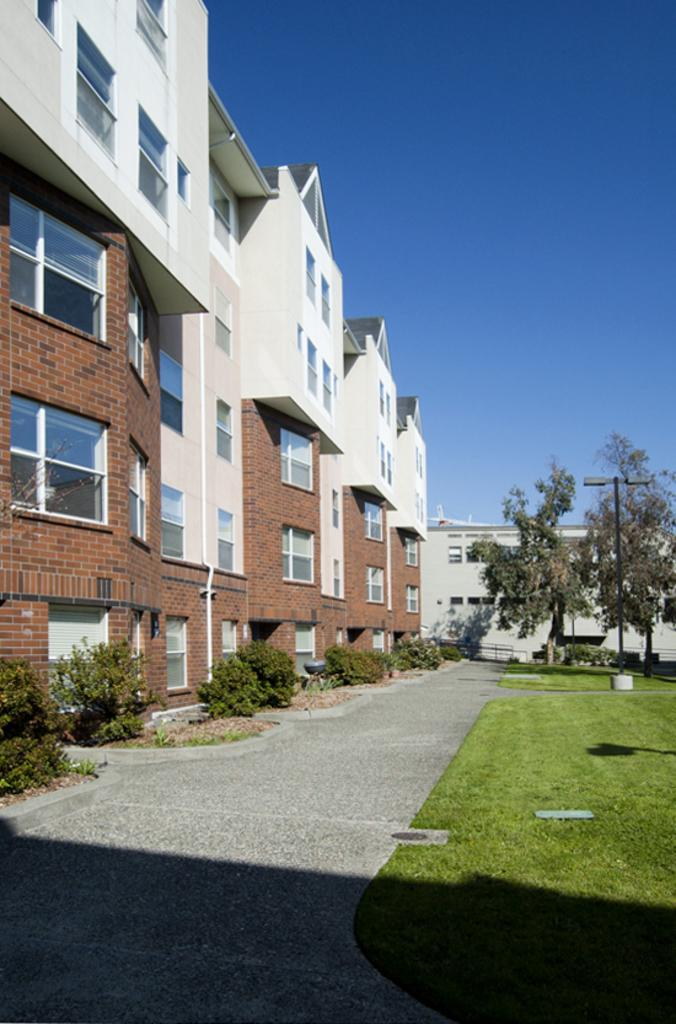What type of surface can be seen in the image? There is a path in the image. What type of vegetation is present in the image? Grass, plants, and trees are visible in the image. What type of artificial lighting is present in the image? There are lights in the image. What type of structures are visible in the image? There are buildings in the image. What part of the natural environment is visible in the background of the image? The sky is visible in the background of the image. What effect can be observed due to the presence of the sun in the image? Shadows are present in the image. Can you see any snakes slithering on the path in the image? There are no snakes visible in the image. What color is the crayon used to draw the buildings in the image? There is no crayon present in the image; the buildings are real structures. 